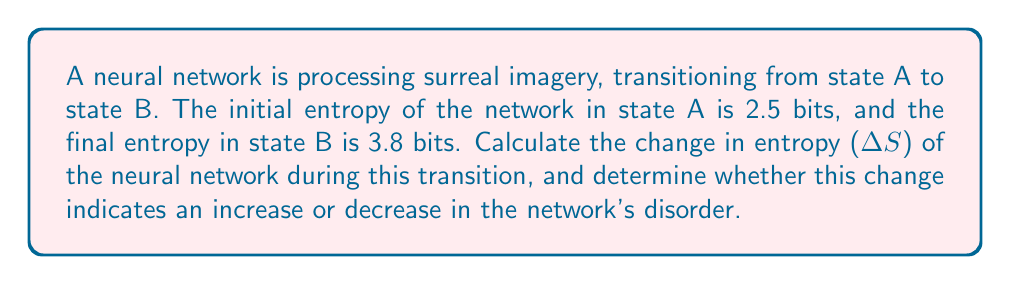Teach me how to tackle this problem. To solve this problem, we'll follow these steps:

1. Identify the given information:
   - Initial entropy (state A): $S_A = 2.5$ bits
   - Final entropy (state B): $S_B = 3.8$ bits

2. Calculate the change in entropy (ΔS):
   The change in entropy is given by the difference between the final and initial states:
   
   $$\Delta S = S_B - S_A$$
   
   Substituting the values:
   
   $$\Delta S = 3.8 \text{ bits} - 2.5 \text{ bits} = 1.3 \text{ bits}$$

3. Interpret the result:
   - A positive ΔS indicates an increase in entropy.
   - An increase in entropy corresponds to an increase in disorder or unpredictability in the system.

In this case, ΔS is positive (1.3 bits), which means the entropy of the neural network has increased during the transition from state A to state B. This suggests that the network's processing of surreal imagery has led to a more disordered or complex state, potentially reflecting the intricate and unconventional nature of surreal art.

From a psychological perspective, this increase in entropy could indicate that the neural network is adapting to the non-conventional patterns and associations present in surreal imagery, potentially mirroring the cognitive processes involved when humans interpret such artworks.
Answer: ΔS = 1.3 bits; entropy increased 